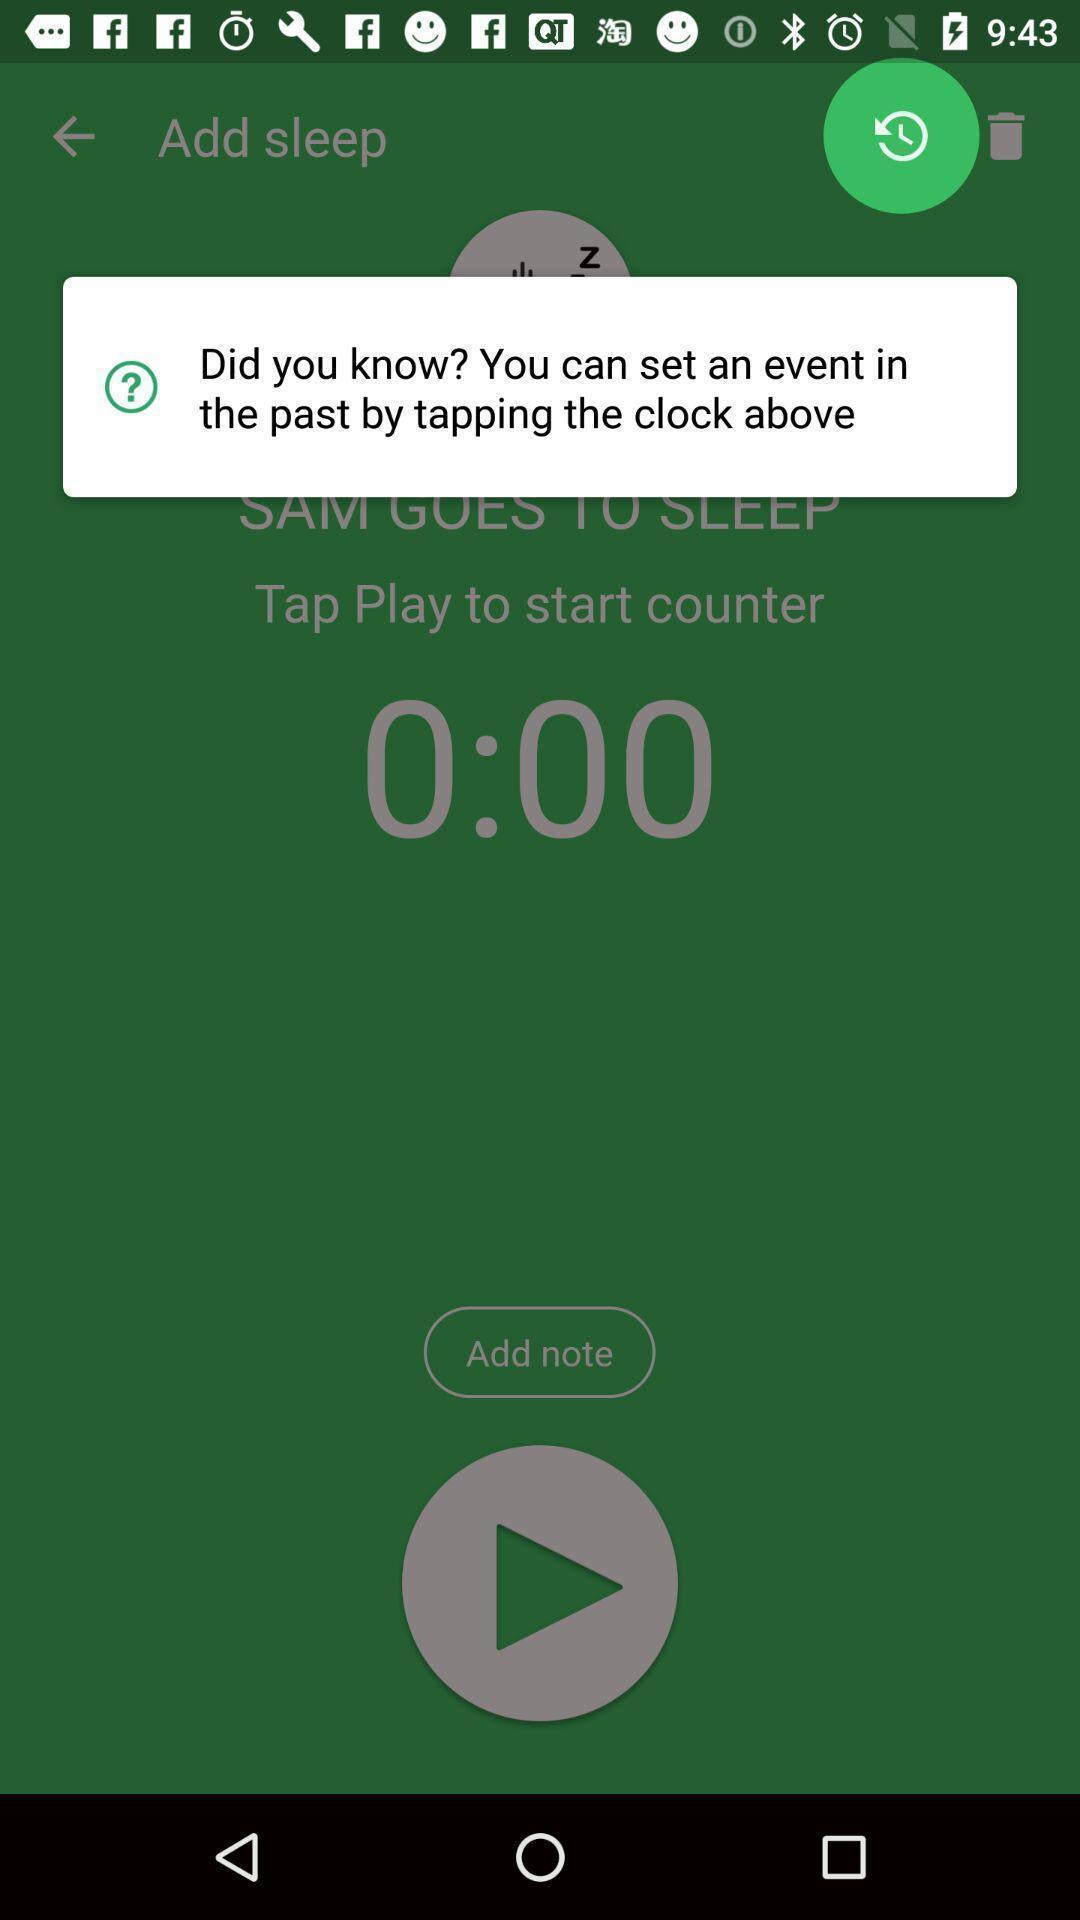Tell me what you see in this picture. Pop-up showing the option to set an event. 